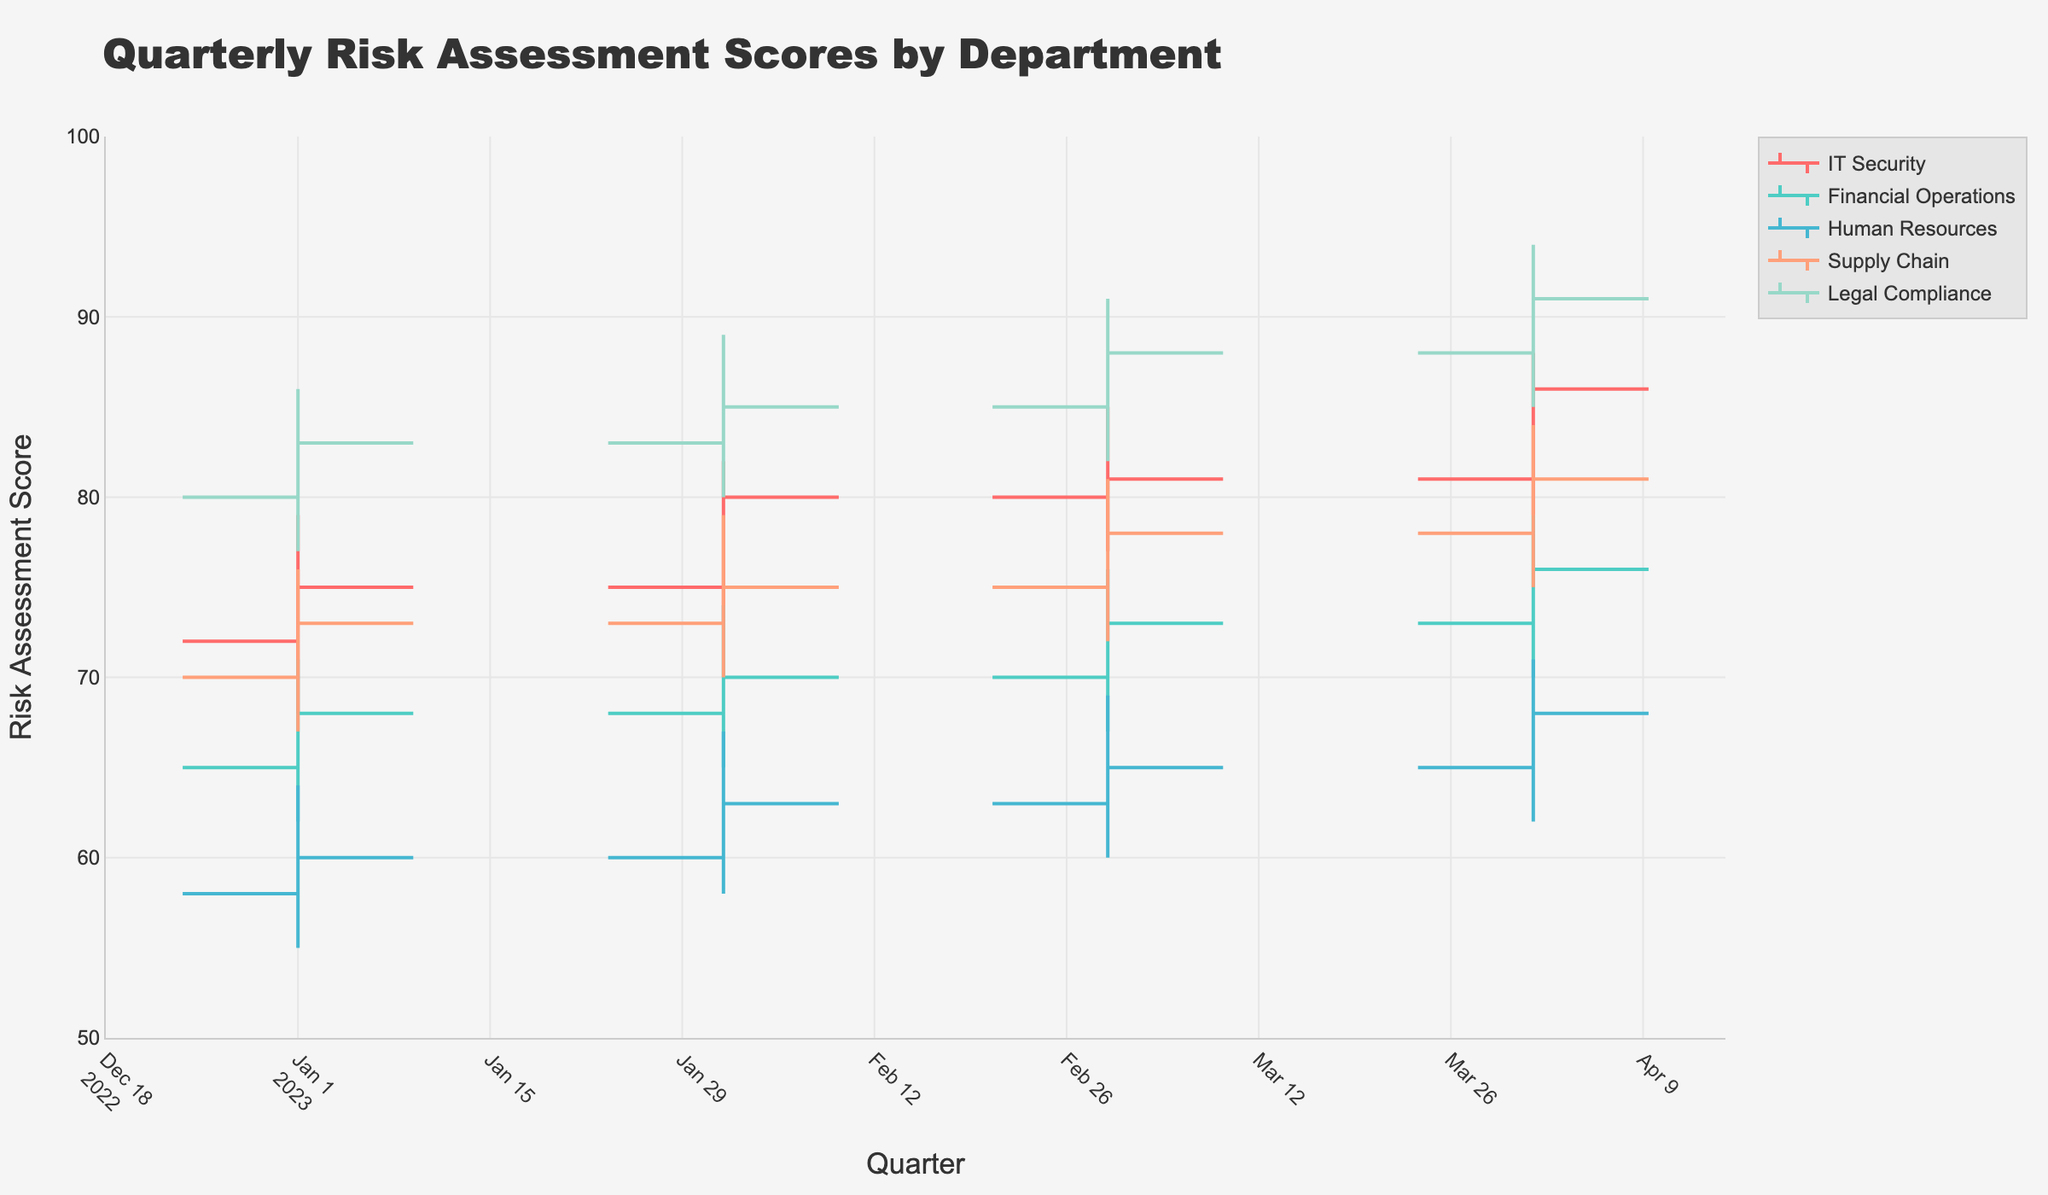How many departments are displayed in the chart? There are five unique department names listed in the legend of the chart. They are IT Security, Financial Operations, Human Resources, Supply Chain, and Legal Compliance.
Answer: Five Which department saw the highest closing risk assessment score in Q4 2023? Find the closing risk assessment scores for Q4 2023 across all departments: IT Security (86), Financial Operations (76), Human Resources (68), Supply Chain (81), Legal Compliance (91). The highest among these is Legal Compliance with a score of 91.
Answer: Legal Compliance Compare the risk assessment score ranges (difference between the high and low) for IT Security and Financial Operations in Q1 2023. Which department had a larger range? For IT Security in Q1 2023, the range is 79 - 68 = 11. For Financial Operations in Q1 2023, the range is 71 - 62 = 9. Therefore, IT Security had a larger range.
Answer: IT Security What is the average closing risk assessment score for the IT Security department over the four quarters of 2023? The closing scores for IT Security in Q1, Q2, Q3, and Q4 2023 are 75, 80, 81, and 86 respectively. The average is (75 + 80 + 81 + 86) / 4 = 80.5.
Answer: 80.5 Which department showed the most consistent (smallest range between high and low) performance in Q3 2023? Evaluate the range by subtracting the low scores from the high scores for each department in Q3 2023: IT Security (85 - 77 = 8), Financial Operations (76 - 67 = 9), Human Resources (69 - 60 = 9), Supply Chain (81 - 72 = 9), Legal Compliance (91 - 82 = 9). IT Security exhibited the smallest range of 8.
Answer: IT Security What was the trend in the closing risk assessment scores for Supply Chain from Q1 to Q4 2023? The closing risk assessment scores for Supply Chain over the quarters are Q1 (73), Q2 (75), Q3 (78), Q4 (81). The scores show a consistent increasing trend.
Answer: Increasing trend Did any department have a quarter where the closing score was identical to the opening score? Check each department's open and close scores across all quarters: IT Security, Financial Operations, Human Resources, Supply Chain, and Legal Compliance. None had identical opening and closing scores in any quarter.
Answer: No What's the difference between the highest recorded risk assessment score and the lowest recorded score across all departments in 2023? The highest recorded score is 94 (Legal Compliance in Q4 2023) and the lowest recorded score is 55 (Human Resources in Q1 2023). The difference is 94 - 55 = 39.
Answer: 39 